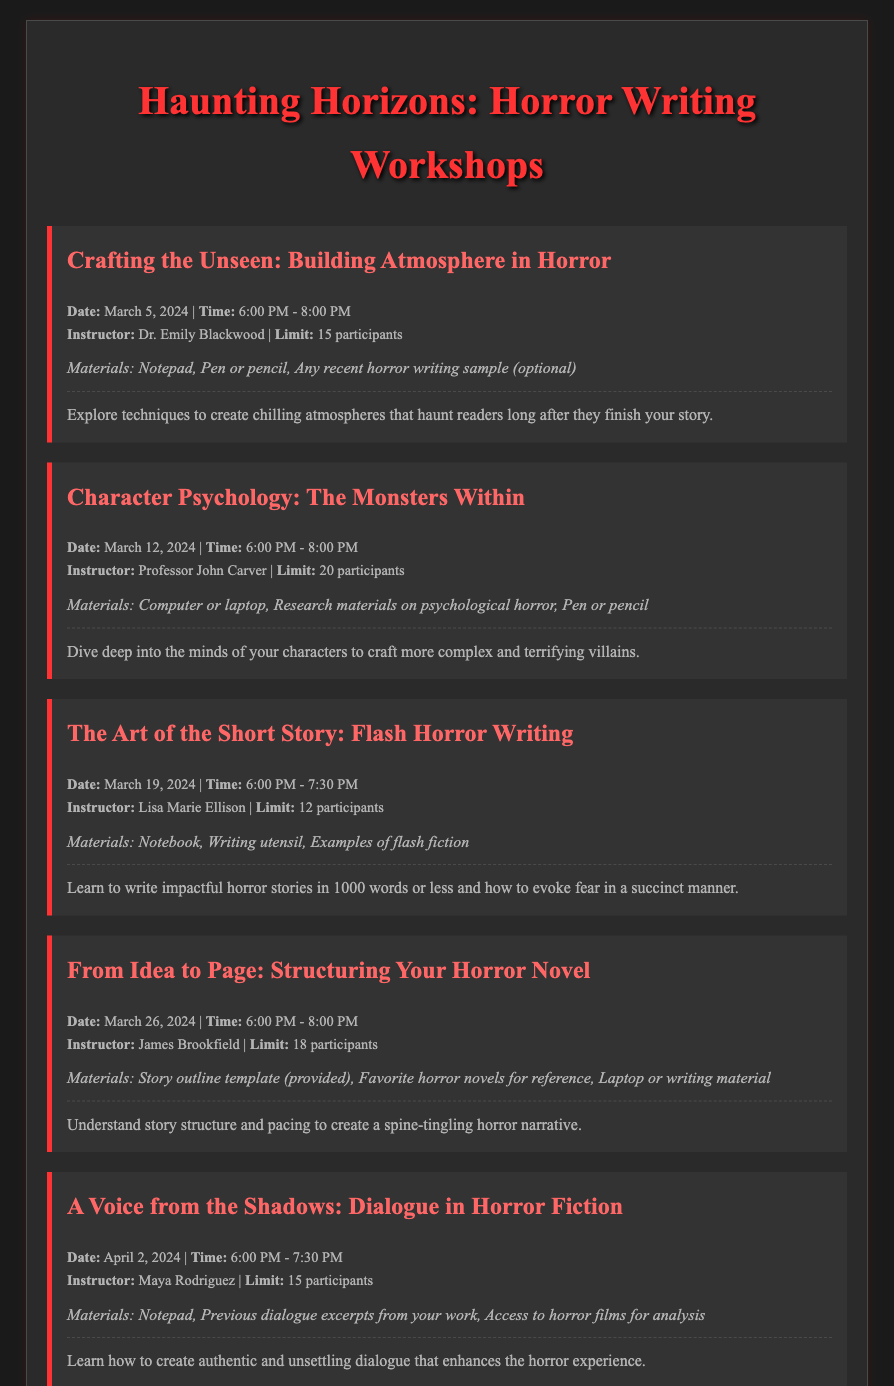What is the date of the first workshop? The date of the first workshop, "Crafting the Unseen: Building Atmosphere in Horror," is listed as March 5, 2024.
Answer: March 5, 2024 Who is the instructor for the workshop on Character Psychology? The instructor for the workshop titled "Character Psychology: The Monsters Within" is Professor John Carver.
Answer: Professor John Carver What is the participant limit for the Flash Horror Writing workshop? The participant limit is specified as 12 for the workshop "The Art of the Short Story: Flash Horror Writing."
Answer: 12 participants What materials are needed for the workshop on dialogue? The materials needed for "A Voice from the Shadows: Dialogue in Horror Fiction" include a notepad, previous dialogue excerpts from your work, and access to horror films for analysis.
Answer: Notepad, Previous dialogue excerpts, Access to horror films What time does the "From Idea to Page: Structuring Your Horror Novel" workshop start? The workshop on structuring horror novels starts at 6:00 PM, as stated in the schedule.
Answer: 6:00 PM 